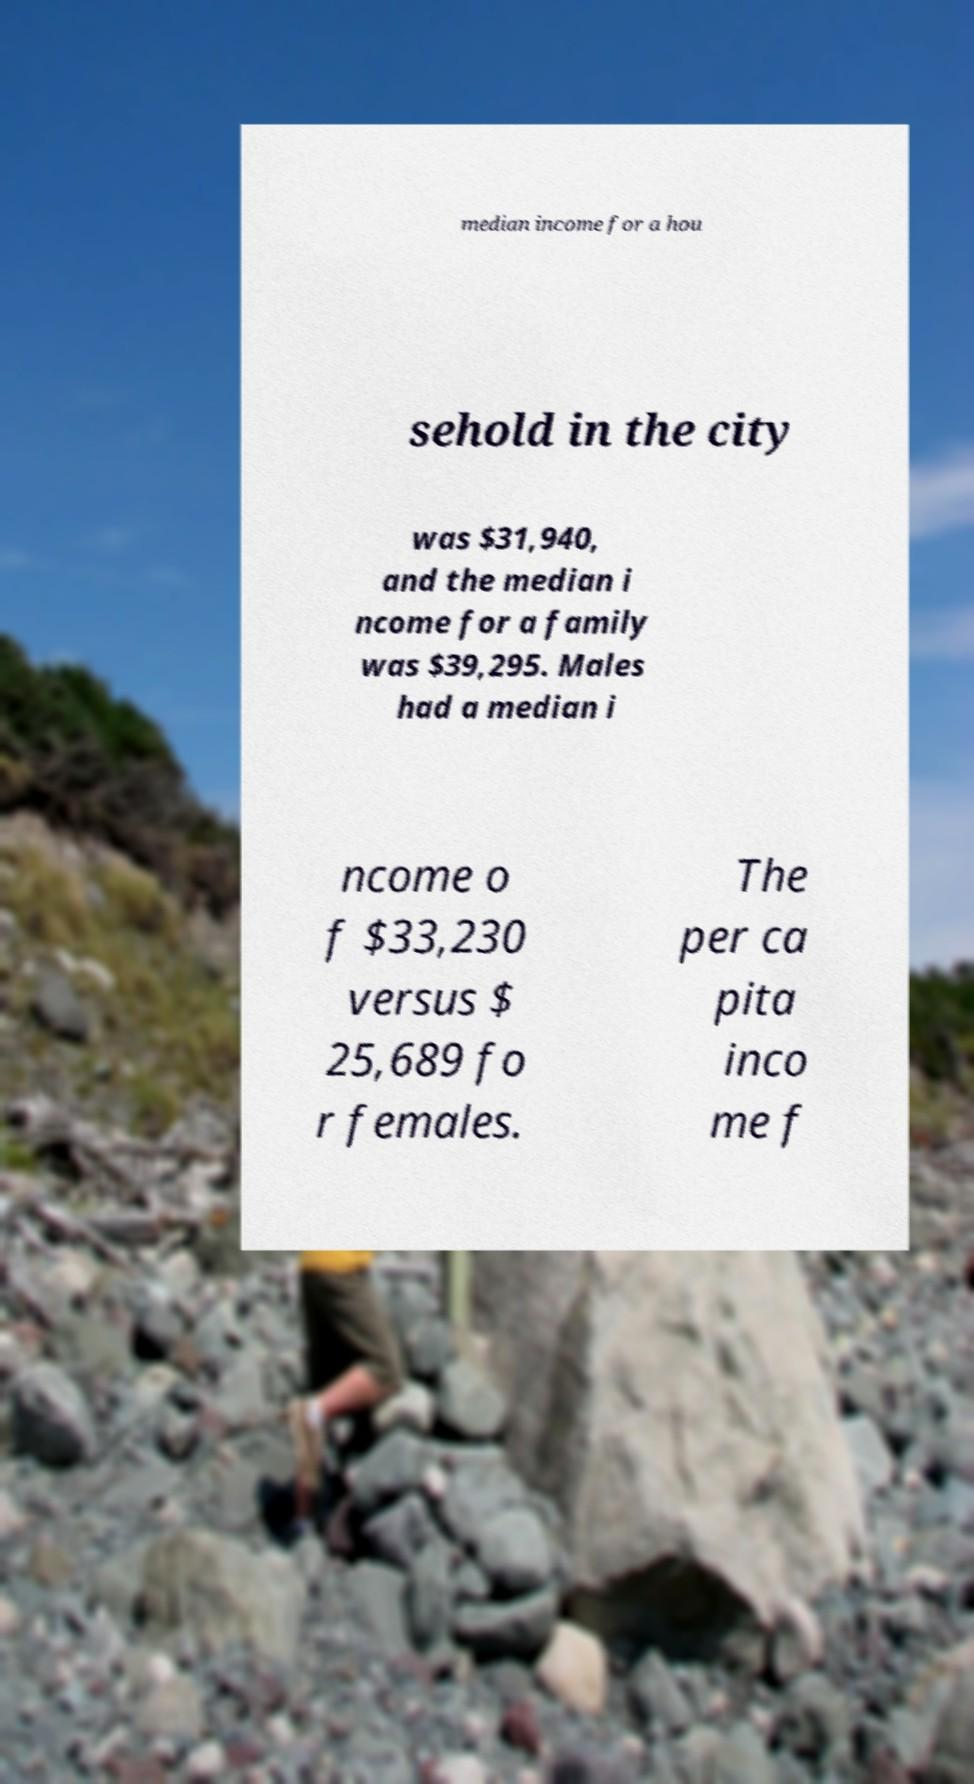Please read and relay the text visible in this image. What does it say? median income for a hou sehold in the city was $31,940, and the median i ncome for a family was $39,295. Males had a median i ncome o f $33,230 versus $ 25,689 fo r females. The per ca pita inco me f 